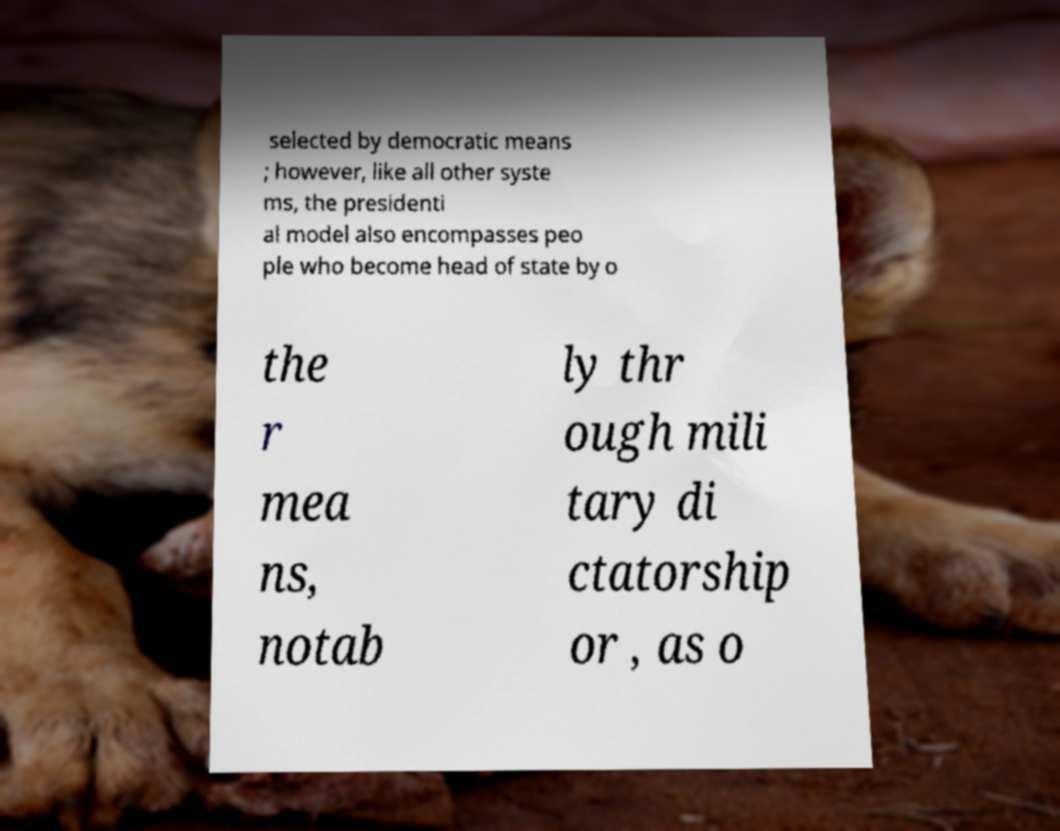Could you assist in decoding the text presented in this image and type it out clearly? selected by democratic means ; however, like all other syste ms, the presidenti al model also encompasses peo ple who become head of state by o the r mea ns, notab ly thr ough mili tary di ctatorship or , as o 